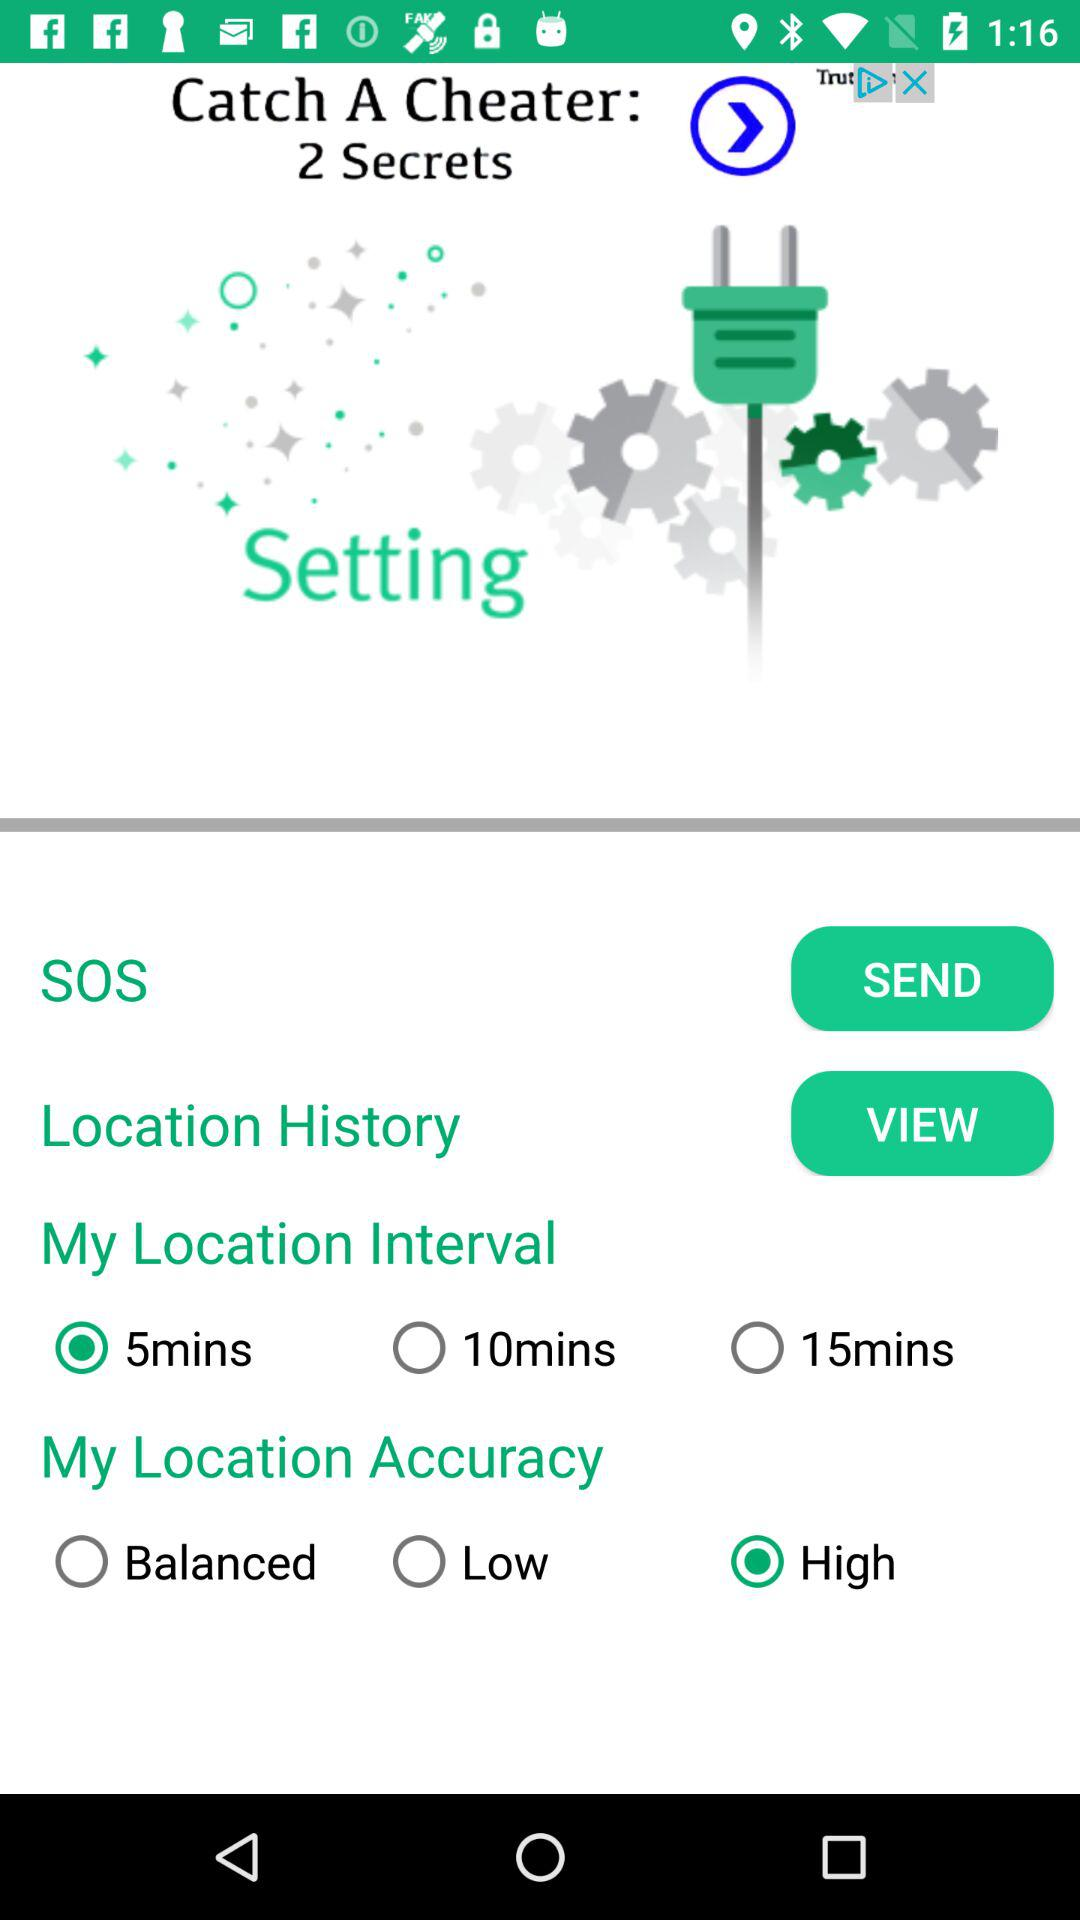How many reviews are there?
When the provided information is insufficient, respond with <no answer>. <no answer> 